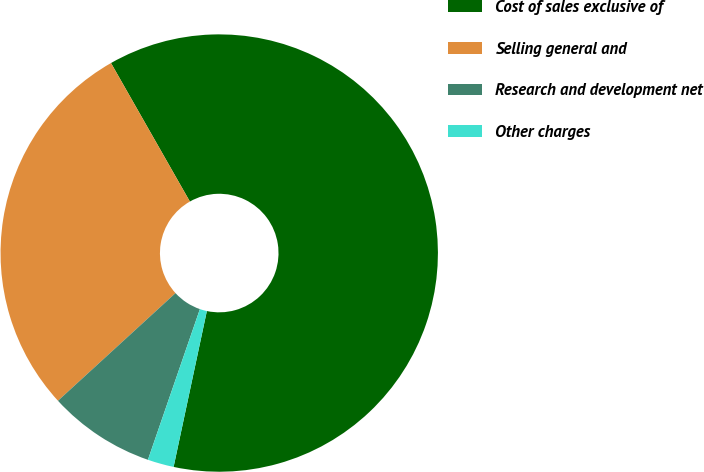<chart> <loc_0><loc_0><loc_500><loc_500><pie_chart><fcel>Cost of sales exclusive of<fcel>Selling general and<fcel>Research and development net<fcel>Other charges<nl><fcel>61.58%<fcel>28.56%<fcel>7.91%<fcel>1.94%<nl></chart> 